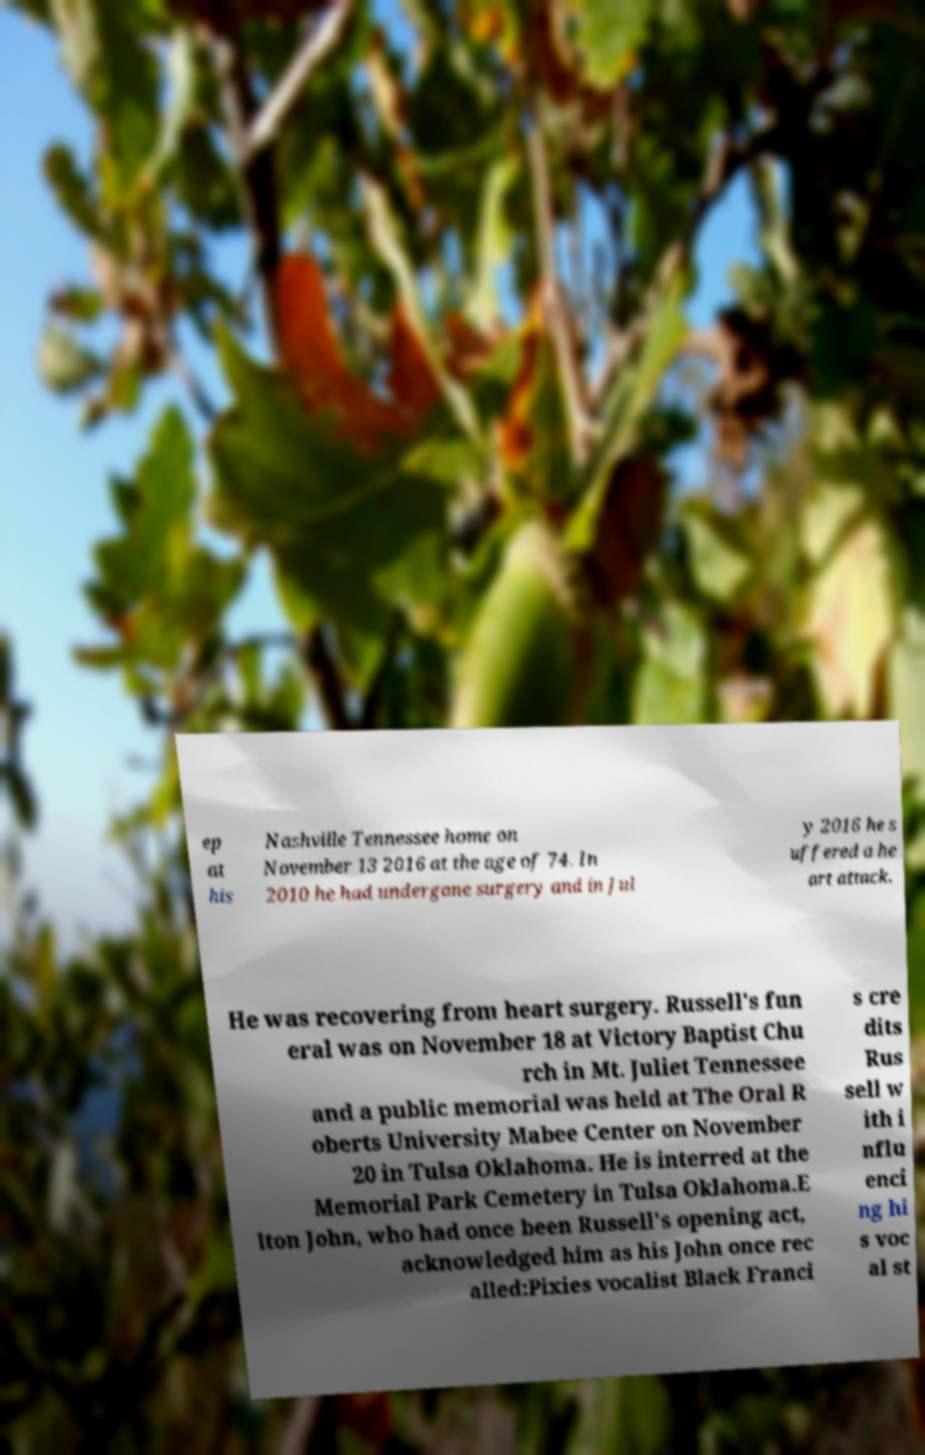Could you assist in decoding the text presented in this image and type it out clearly? ep at his Nashville Tennessee home on November 13 2016 at the age of 74. In 2010 he had undergone surgery and in Jul y 2016 he s uffered a he art attack. He was recovering from heart surgery. Russell's fun eral was on November 18 at Victory Baptist Chu rch in Mt. Juliet Tennessee and a public memorial was held at The Oral R oberts University Mabee Center on November 20 in Tulsa Oklahoma. He is interred at the Memorial Park Cemetery in Tulsa Oklahoma.E lton John, who had once been Russell's opening act, acknowledged him as his John once rec alled:Pixies vocalist Black Franci s cre dits Rus sell w ith i nflu enci ng hi s voc al st 